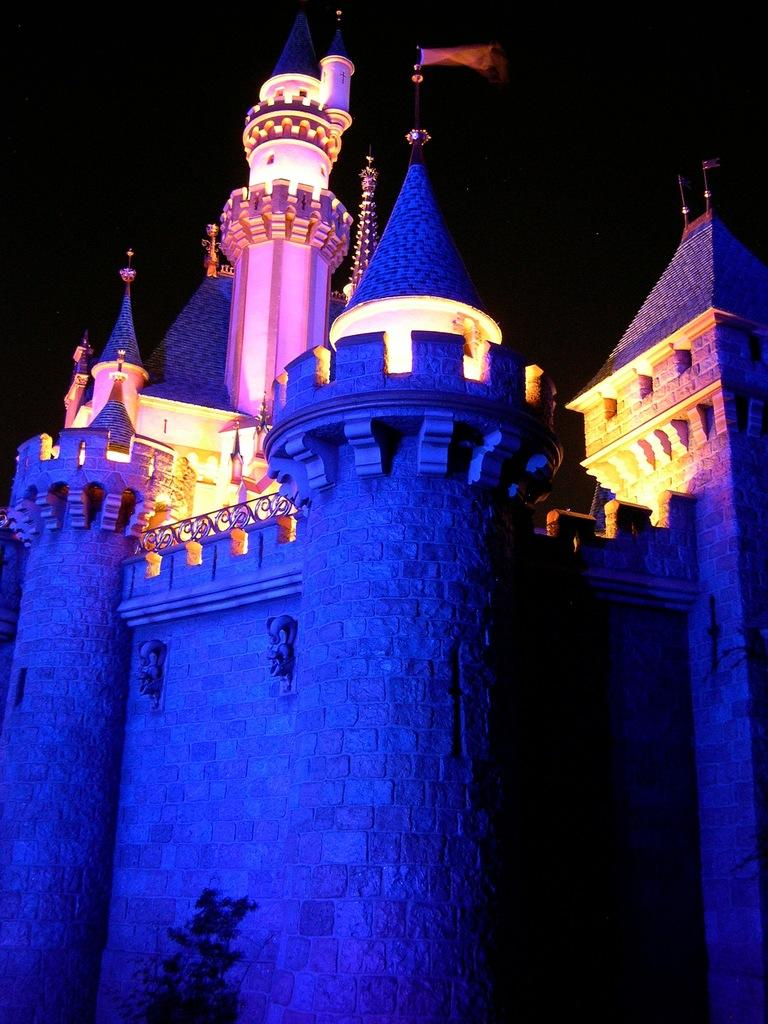What is the main subject in the center of the image? There is a flag in the center of the image. Where is the flag located? The flag is on a castle. What can be seen in the background of the image? There is sky visible in the background of the image. What type of paper is being used to hold up the castle in the image? There is no paper present in the image, and the castle is not being held up by any object. 